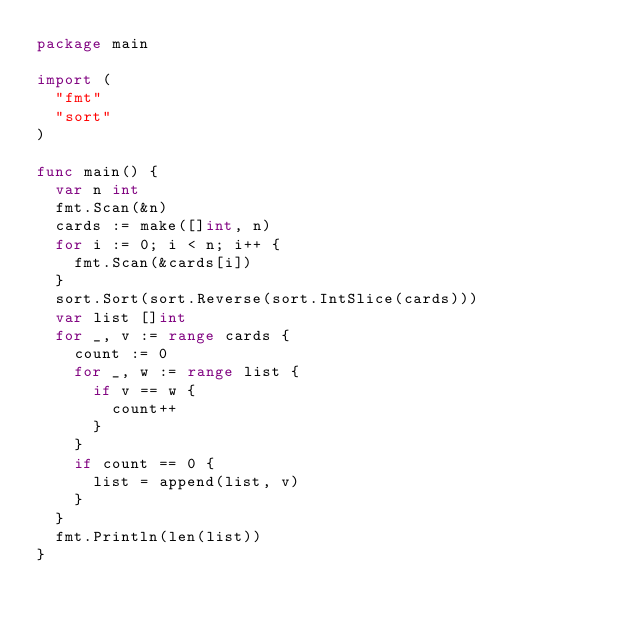<code> <loc_0><loc_0><loc_500><loc_500><_Go_>package main

import (
  "fmt"
  "sort"
)

func main() {
  var n int
  fmt.Scan(&n)
  cards := make([]int, n)
  for i := 0; i < n; i++ {
    fmt.Scan(&cards[i])
  }
  sort.Sort(sort.Reverse(sort.IntSlice(cards)))
  var list []int
  for _, v := range cards {
    count := 0
    for _, w := range list {
      if v == w {
        count++
      }
    }
    if count == 0 {
      list = append(list, v)
    }
  }
  fmt.Println(len(list))
}</code> 